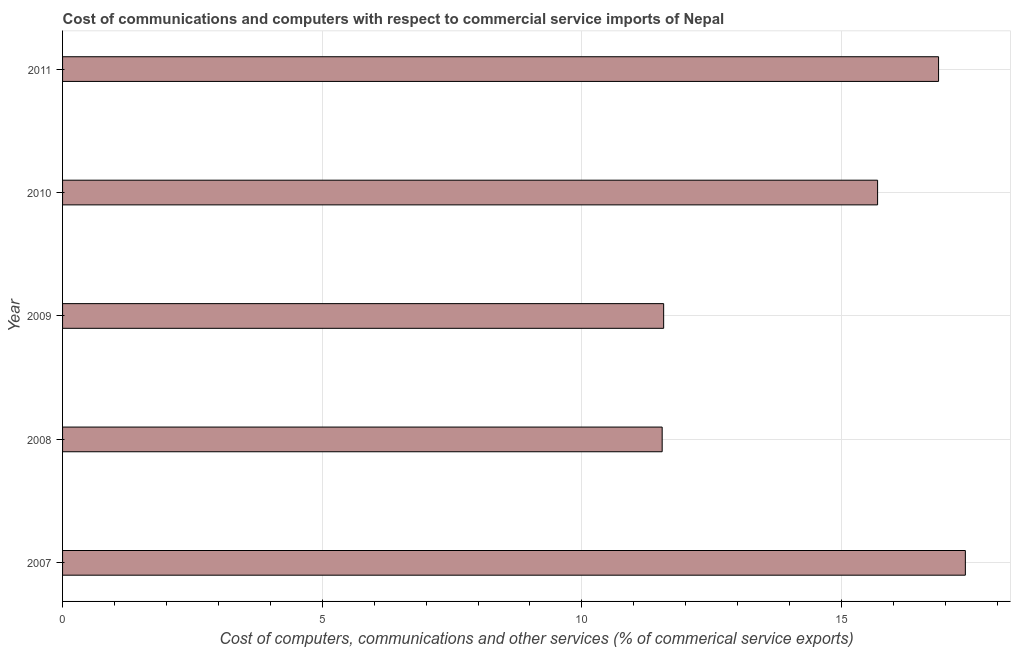What is the title of the graph?
Give a very brief answer. Cost of communications and computers with respect to commercial service imports of Nepal. What is the label or title of the X-axis?
Your answer should be compact. Cost of computers, communications and other services (% of commerical service exports). What is the label or title of the Y-axis?
Ensure brevity in your answer.  Year. What is the  computer and other services in 2008?
Your response must be concise. 11.55. Across all years, what is the maximum cost of communications?
Your answer should be compact. 17.38. Across all years, what is the minimum cost of communications?
Ensure brevity in your answer.  11.55. What is the sum of the cost of communications?
Provide a succinct answer. 73.07. What is the difference between the cost of communications in 2009 and 2010?
Provide a short and direct response. -4.12. What is the average cost of communications per year?
Make the answer very short. 14.61. What is the median cost of communications?
Offer a terse response. 15.69. What is the ratio of the cost of communications in 2007 to that in 2009?
Offer a terse response. 1.5. Is the difference between the cost of communications in 2009 and 2011 greater than the difference between any two years?
Your answer should be compact. No. What is the difference between the highest and the second highest  computer and other services?
Offer a terse response. 0.52. Is the sum of the  computer and other services in 2008 and 2009 greater than the maximum  computer and other services across all years?
Ensure brevity in your answer.  Yes. What is the difference between the highest and the lowest  computer and other services?
Keep it short and to the point. 5.84. In how many years, is the  computer and other services greater than the average  computer and other services taken over all years?
Ensure brevity in your answer.  3. Are all the bars in the graph horizontal?
Ensure brevity in your answer.  Yes. How many years are there in the graph?
Your answer should be compact. 5. Are the values on the major ticks of X-axis written in scientific E-notation?
Keep it short and to the point. No. What is the Cost of computers, communications and other services (% of commerical service exports) of 2007?
Provide a short and direct response. 17.38. What is the Cost of computers, communications and other services (% of commerical service exports) in 2008?
Provide a succinct answer. 11.55. What is the Cost of computers, communications and other services (% of commerical service exports) in 2009?
Your answer should be very brief. 11.57. What is the Cost of computers, communications and other services (% of commerical service exports) in 2010?
Keep it short and to the point. 15.69. What is the Cost of computers, communications and other services (% of commerical service exports) of 2011?
Make the answer very short. 16.87. What is the difference between the Cost of computers, communications and other services (% of commerical service exports) in 2007 and 2008?
Your answer should be very brief. 5.84. What is the difference between the Cost of computers, communications and other services (% of commerical service exports) in 2007 and 2009?
Keep it short and to the point. 5.81. What is the difference between the Cost of computers, communications and other services (% of commerical service exports) in 2007 and 2010?
Make the answer very short. 1.69. What is the difference between the Cost of computers, communications and other services (% of commerical service exports) in 2007 and 2011?
Offer a very short reply. 0.52. What is the difference between the Cost of computers, communications and other services (% of commerical service exports) in 2008 and 2009?
Provide a succinct answer. -0.03. What is the difference between the Cost of computers, communications and other services (% of commerical service exports) in 2008 and 2010?
Provide a succinct answer. -4.15. What is the difference between the Cost of computers, communications and other services (% of commerical service exports) in 2008 and 2011?
Give a very brief answer. -5.32. What is the difference between the Cost of computers, communications and other services (% of commerical service exports) in 2009 and 2010?
Keep it short and to the point. -4.12. What is the difference between the Cost of computers, communications and other services (% of commerical service exports) in 2009 and 2011?
Your response must be concise. -5.29. What is the difference between the Cost of computers, communications and other services (% of commerical service exports) in 2010 and 2011?
Your answer should be very brief. -1.17. What is the ratio of the Cost of computers, communications and other services (% of commerical service exports) in 2007 to that in 2008?
Keep it short and to the point. 1.51. What is the ratio of the Cost of computers, communications and other services (% of commerical service exports) in 2007 to that in 2009?
Your answer should be very brief. 1.5. What is the ratio of the Cost of computers, communications and other services (% of commerical service exports) in 2007 to that in 2010?
Keep it short and to the point. 1.11. What is the ratio of the Cost of computers, communications and other services (% of commerical service exports) in 2007 to that in 2011?
Your response must be concise. 1.03. What is the ratio of the Cost of computers, communications and other services (% of commerical service exports) in 2008 to that in 2009?
Keep it short and to the point. 1. What is the ratio of the Cost of computers, communications and other services (% of commerical service exports) in 2008 to that in 2010?
Provide a succinct answer. 0.74. What is the ratio of the Cost of computers, communications and other services (% of commerical service exports) in 2008 to that in 2011?
Ensure brevity in your answer.  0.68. What is the ratio of the Cost of computers, communications and other services (% of commerical service exports) in 2009 to that in 2010?
Make the answer very short. 0.74. What is the ratio of the Cost of computers, communications and other services (% of commerical service exports) in 2009 to that in 2011?
Give a very brief answer. 0.69. What is the ratio of the Cost of computers, communications and other services (% of commerical service exports) in 2010 to that in 2011?
Provide a succinct answer. 0.93. 